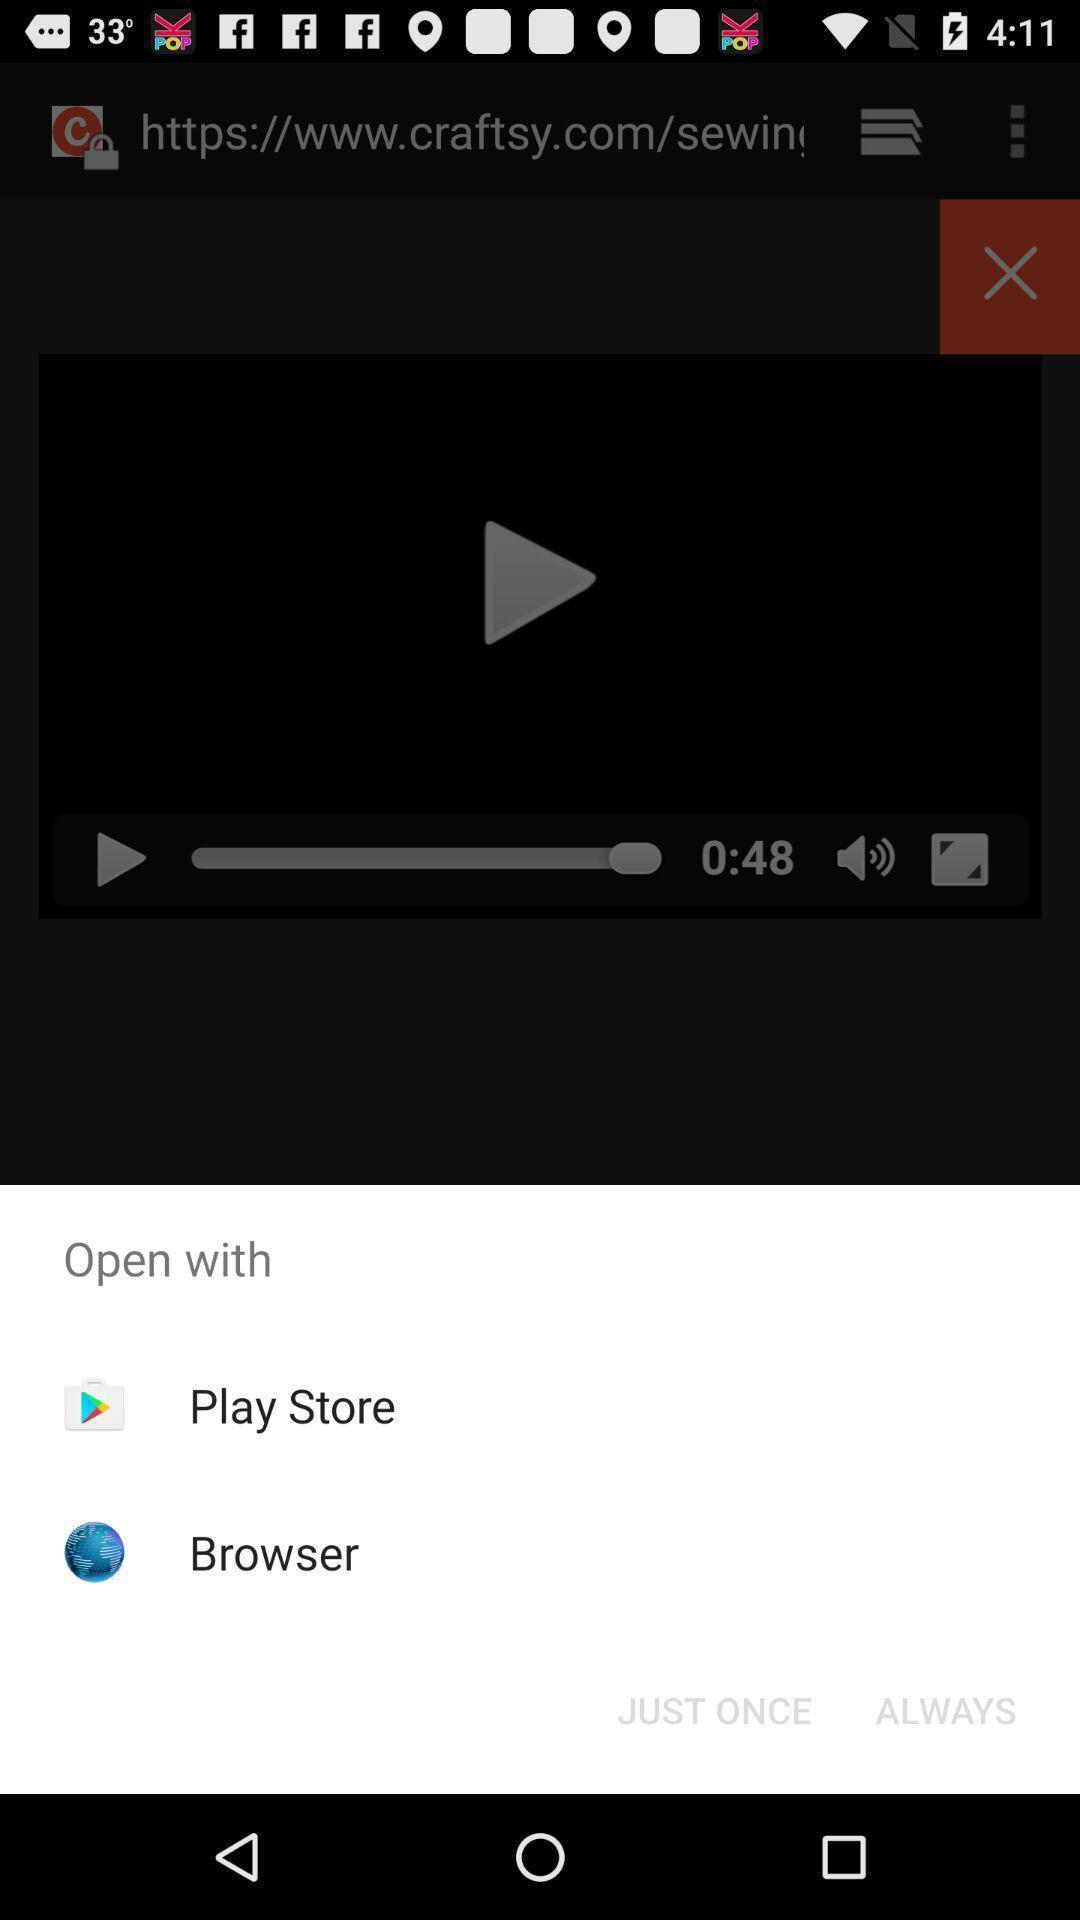Provide a textual representation of this image. Popup showing different apps to open with. 